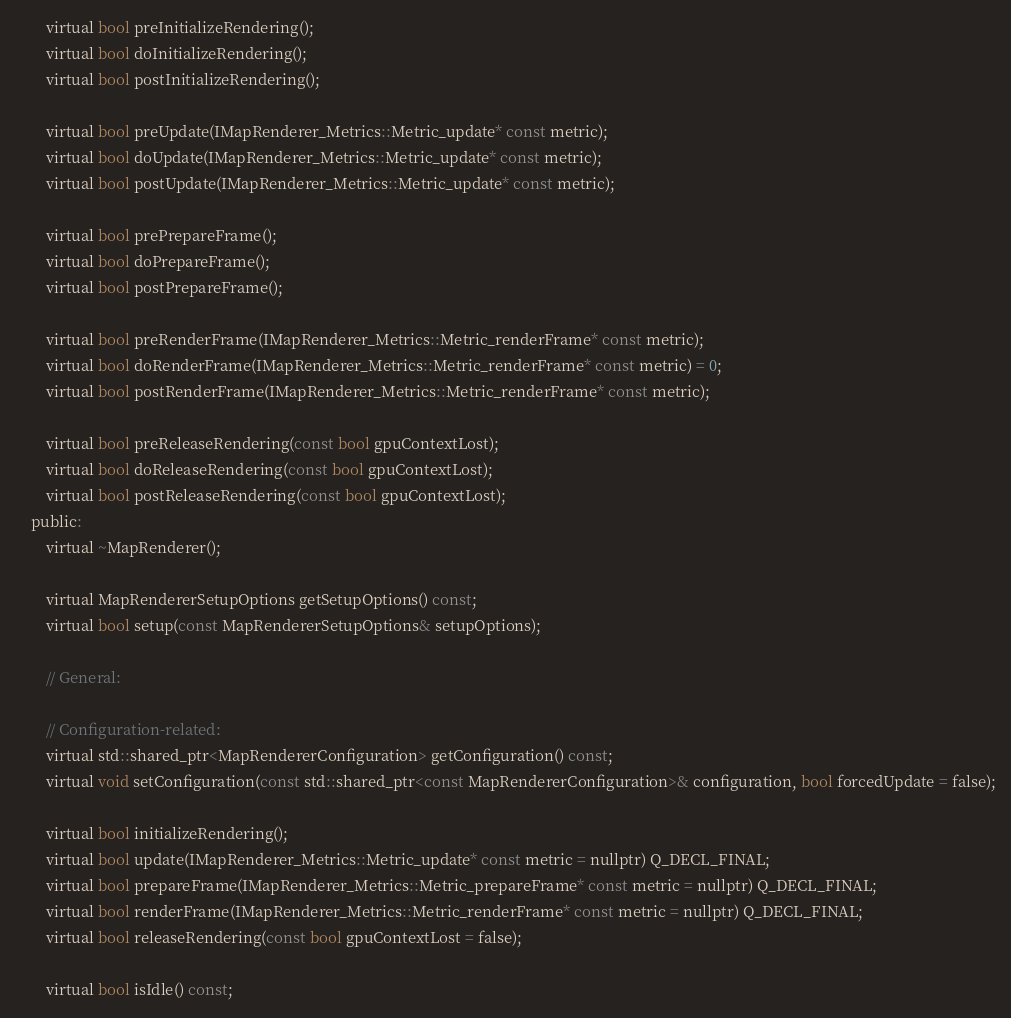<code> <loc_0><loc_0><loc_500><loc_500><_C_>        virtual bool preInitializeRendering();
        virtual bool doInitializeRendering();
        virtual bool postInitializeRendering();

        virtual bool preUpdate(IMapRenderer_Metrics::Metric_update* const metric);
        virtual bool doUpdate(IMapRenderer_Metrics::Metric_update* const metric);
        virtual bool postUpdate(IMapRenderer_Metrics::Metric_update* const metric);

        virtual bool prePrepareFrame();
        virtual bool doPrepareFrame();
        virtual bool postPrepareFrame();

        virtual bool preRenderFrame(IMapRenderer_Metrics::Metric_renderFrame* const metric);
        virtual bool doRenderFrame(IMapRenderer_Metrics::Metric_renderFrame* const metric) = 0;
        virtual bool postRenderFrame(IMapRenderer_Metrics::Metric_renderFrame* const metric);

        virtual bool preReleaseRendering(const bool gpuContextLost);
        virtual bool doReleaseRendering(const bool gpuContextLost);
        virtual bool postReleaseRendering(const bool gpuContextLost);
    public:
        virtual ~MapRenderer();

        virtual MapRendererSetupOptions getSetupOptions() const;
        virtual bool setup(const MapRendererSetupOptions& setupOptions);

        // General:

        // Configuration-related:
        virtual std::shared_ptr<MapRendererConfiguration> getConfiguration() const;
        virtual void setConfiguration(const std::shared_ptr<const MapRendererConfiguration>& configuration, bool forcedUpdate = false);

        virtual bool initializeRendering();
        virtual bool update(IMapRenderer_Metrics::Metric_update* const metric = nullptr) Q_DECL_FINAL;
        virtual bool prepareFrame(IMapRenderer_Metrics::Metric_prepareFrame* const metric = nullptr) Q_DECL_FINAL;
        virtual bool renderFrame(IMapRenderer_Metrics::Metric_renderFrame* const metric = nullptr) Q_DECL_FINAL;
        virtual bool releaseRendering(const bool gpuContextLost = false);

        virtual bool isIdle() const;</code> 